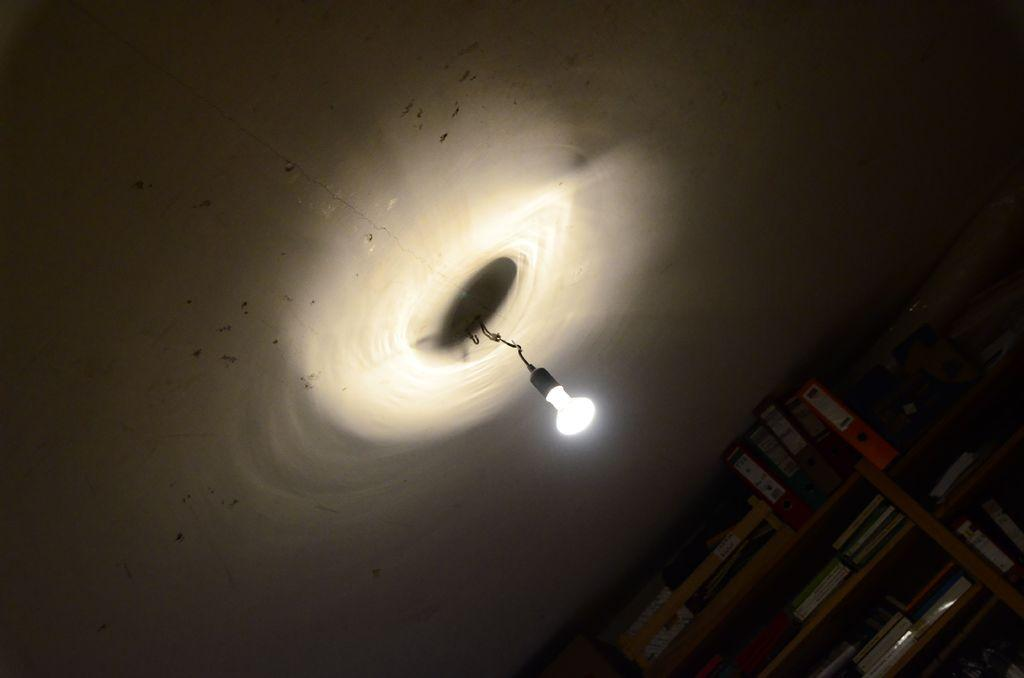What items can be seen in the image related to reading or organizing information? There are books and files in the image. How are the books and files arranged in the image? The books and files are placed in a rack. What is the source of light in the image? There is a light in the center of the image. What architectural feature can be seen in the background of the image? There is a roof visible in the background of the image. What type of cream is being used to paint the zephyr in the image? There is no cream or zephyr present in the image; it features books, files, a rack, a light, and a roof. 